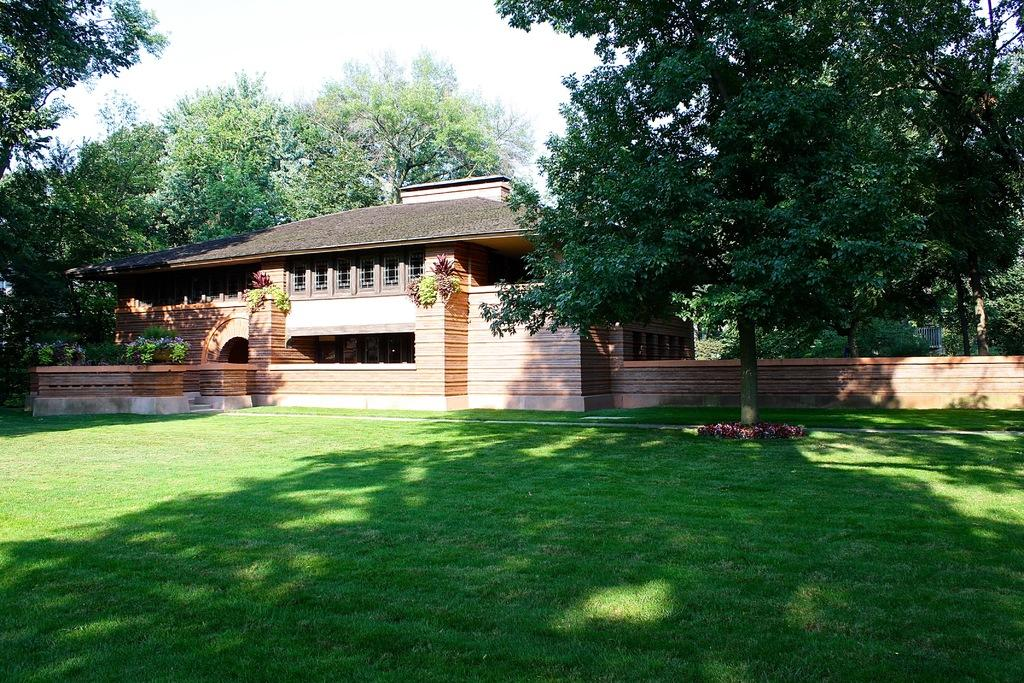What type of structure is visible in the image? There is a house in the image. What can be seen surrounding the house? There are many trees around the house. What is located in front of the house? There is a garden in front of the house. What type of zephyr can be seen blowing through the garden in the image? There is no mention of a zephyr in the image, and therefore it cannot be seen blowing through the garden. 